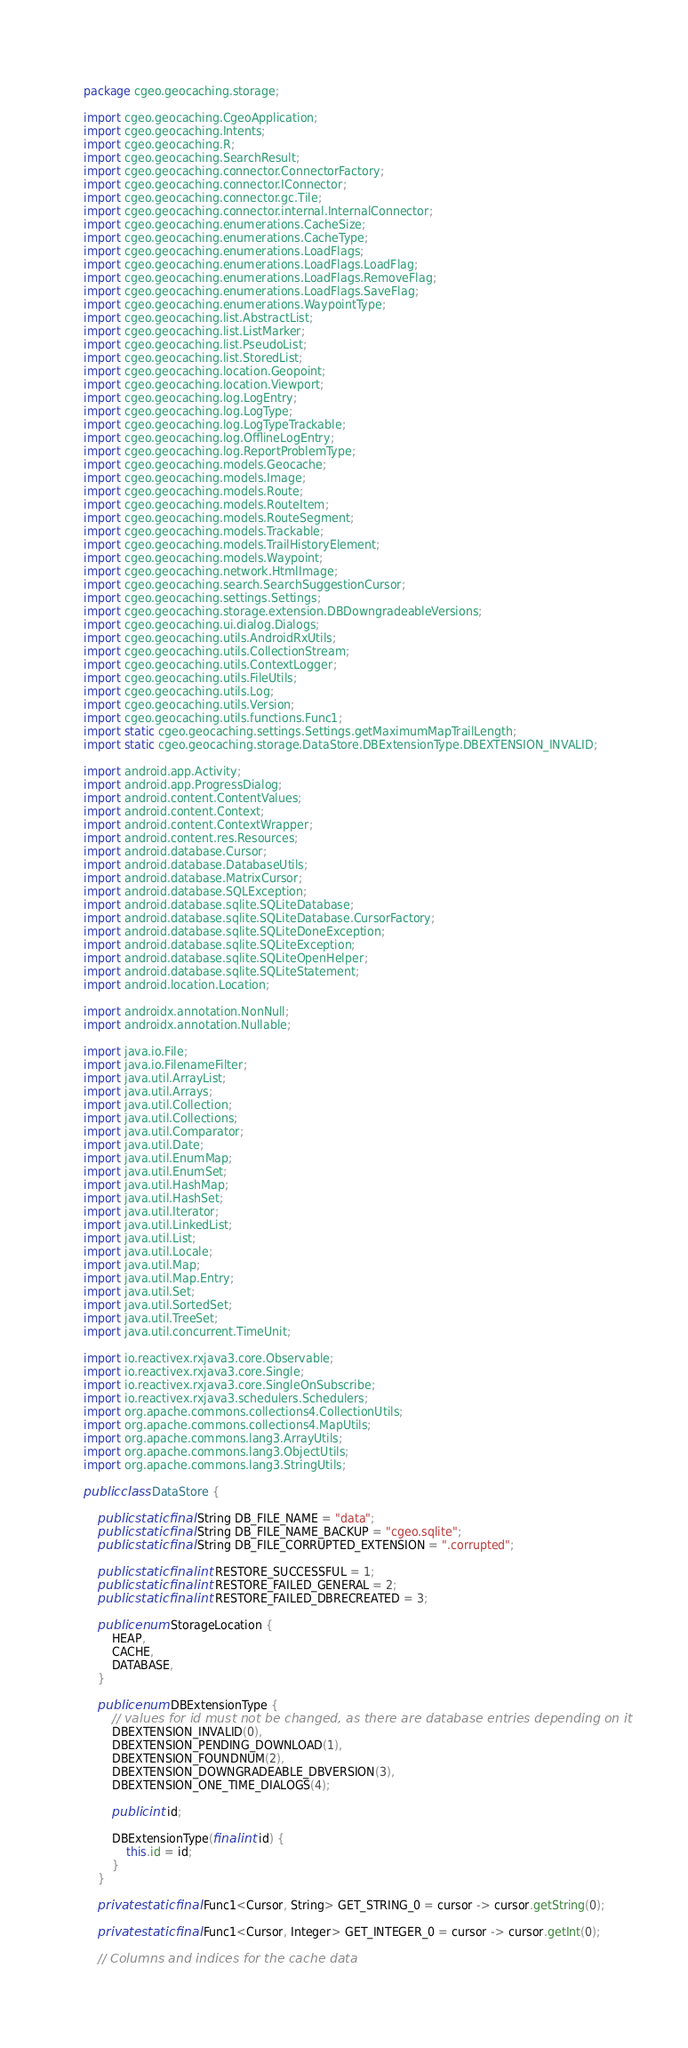<code> <loc_0><loc_0><loc_500><loc_500><_Java_>package cgeo.geocaching.storage;

import cgeo.geocaching.CgeoApplication;
import cgeo.geocaching.Intents;
import cgeo.geocaching.R;
import cgeo.geocaching.SearchResult;
import cgeo.geocaching.connector.ConnectorFactory;
import cgeo.geocaching.connector.IConnector;
import cgeo.geocaching.connector.gc.Tile;
import cgeo.geocaching.connector.internal.InternalConnector;
import cgeo.geocaching.enumerations.CacheSize;
import cgeo.geocaching.enumerations.CacheType;
import cgeo.geocaching.enumerations.LoadFlags;
import cgeo.geocaching.enumerations.LoadFlags.LoadFlag;
import cgeo.geocaching.enumerations.LoadFlags.RemoveFlag;
import cgeo.geocaching.enumerations.LoadFlags.SaveFlag;
import cgeo.geocaching.enumerations.WaypointType;
import cgeo.geocaching.list.AbstractList;
import cgeo.geocaching.list.ListMarker;
import cgeo.geocaching.list.PseudoList;
import cgeo.geocaching.list.StoredList;
import cgeo.geocaching.location.Geopoint;
import cgeo.geocaching.location.Viewport;
import cgeo.geocaching.log.LogEntry;
import cgeo.geocaching.log.LogType;
import cgeo.geocaching.log.LogTypeTrackable;
import cgeo.geocaching.log.OfflineLogEntry;
import cgeo.geocaching.log.ReportProblemType;
import cgeo.geocaching.models.Geocache;
import cgeo.geocaching.models.Image;
import cgeo.geocaching.models.Route;
import cgeo.geocaching.models.RouteItem;
import cgeo.geocaching.models.RouteSegment;
import cgeo.geocaching.models.Trackable;
import cgeo.geocaching.models.TrailHistoryElement;
import cgeo.geocaching.models.Waypoint;
import cgeo.geocaching.network.HtmlImage;
import cgeo.geocaching.search.SearchSuggestionCursor;
import cgeo.geocaching.settings.Settings;
import cgeo.geocaching.storage.extension.DBDowngradeableVersions;
import cgeo.geocaching.ui.dialog.Dialogs;
import cgeo.geocaching.utils.AndroidRxUtils;
import cgeo.geocaching.utils.CollectionStream;
import cgeo.geocaching.utils.ContextLogger;
import cgeo.geocaching.utils.FileUtils;
import cgeo.geocaching.utils.Log;
import cgeo.geocaching.utils.Version;
import cgeo.geocaching.utils.functions.Func1;
import static cgeo.geocaching.settings.Settings.getMaximumMapTrailLength;
import static cgeo.geocaching.storage.DataStore.DBExtensionType.DBEXTENSION_INVALID;

import android.app.Activity;
import android.app.ProgressDialog;
import android.content.ContentValues;
import android.content.Context;
import android.content.ContextWrapper;
import android.content.res.Resources;
import android.database.Cursor;
import android.database.DatabaseUtils;
import android.database.MatrixCursor;
import android.database.SQLException;
import android.database.sqlite.SQLiteDatabase;
import android.database.sqlite.SQLiteDatabase.CursorFactory;
import android.database.sqlite.SQLiteDoneException;
import android.database.sqlite.SQLiteException;
import android.database.sqlite.SQLiteOpenHelper;
import android.database.sqlite.SQLiteStatement;
import android.location.Location;

import androidx.annotation.NonNull;
import androidx.annotation.Nullable;

import java.io.File;
import java.io.FilenameFilter;
import java.util.ArrayList;
import java.util.Arrays;
import java.util.Collection;
import java.util.Collections;
import java.util.Comparator;
import java.util.Date;
import java.util.EnumMap;
import java.util.EnumSet;
import java.util.HashMap;
import java.util.HashSet;
import java.util.Iterator;
import java.util.LinkedList;
import java.util.List;
import java.util.Locale;
import java.util.Map;
import java.util.Map.Entry;
import java.util.Set;
import java.util.SortedSet;
import java.util.TreeSet;
import java.util.concurrent.TimeUnit;

import io.reactivex.rxjava3.core.Observable;
import io.reactivex.rxjava3.core.Single;
import io.reactivex.rxjava3.core.SingleOnSubscribe;
import io.reactivex.rxjava3.schedulers.Schedulers;
import org.apache.commons.collections4.CollectionUtils;
import org.apache.commons.collections4.MapUtils;
import org.apache.commons.lang3.ArrayUtils;
import org.apache.commons.lang3.ObjectUtils;
import org.apache.commons.lang3.StringUtils;

public class DataStore {

    public static final String DB_FILE_NAME = "data";
    public static final String DB_FILE_NAME_BACKUP = "cgeo.sqlite";
    public static final String DB_FILE_CORRUPTED_EXTENSION = ".corrupted";

    public static final int RESTORE_SUCCESSFUL = 1;
    public static final int RESTORE_FAILED_GENERAL = 2;
    public static final int RESTORE_FAILED_DBRECREATED = 3;

    public enum StorageLocation {
        HEAP,
        CACHE,
        DATABASE,
    }

    public enum DBExtensionType {
        // values for id must not be changed, as there are database entries depending on it
        DBEXTENSION_INVALID(0),
        DBEXTENSION_PENDING_DOWNLOAD(1),
        DBEXTENSION_FOUNDNUM(2),
        DBEXTENSION_DOWNGRADEABLE_DBVERSION(3),
        DBEXTENSION_ONE_TIME_DIALOGS(4);

        public int id;

        DBExtensionType(final int id) {
            this.id = id;
        }
    }

    private static final Func1<Cursor, String> GET_STRING_0 = cursor -> cursor.getString(0);

    private static final Func1<Cursor, Integer> GET_INTEGER_0 = cursor -> cursor.getInt(0);

    // Columns and indices for the cache data</code> 